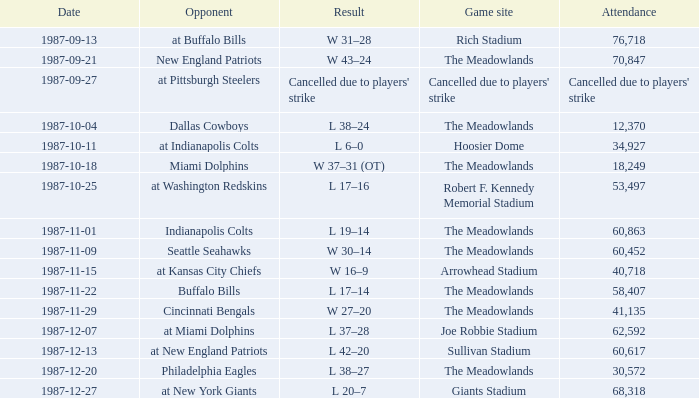Who did the Jets play in their pre-week 9 game at the Robert F. Kennedy memorial stadium? At washington redskins. 